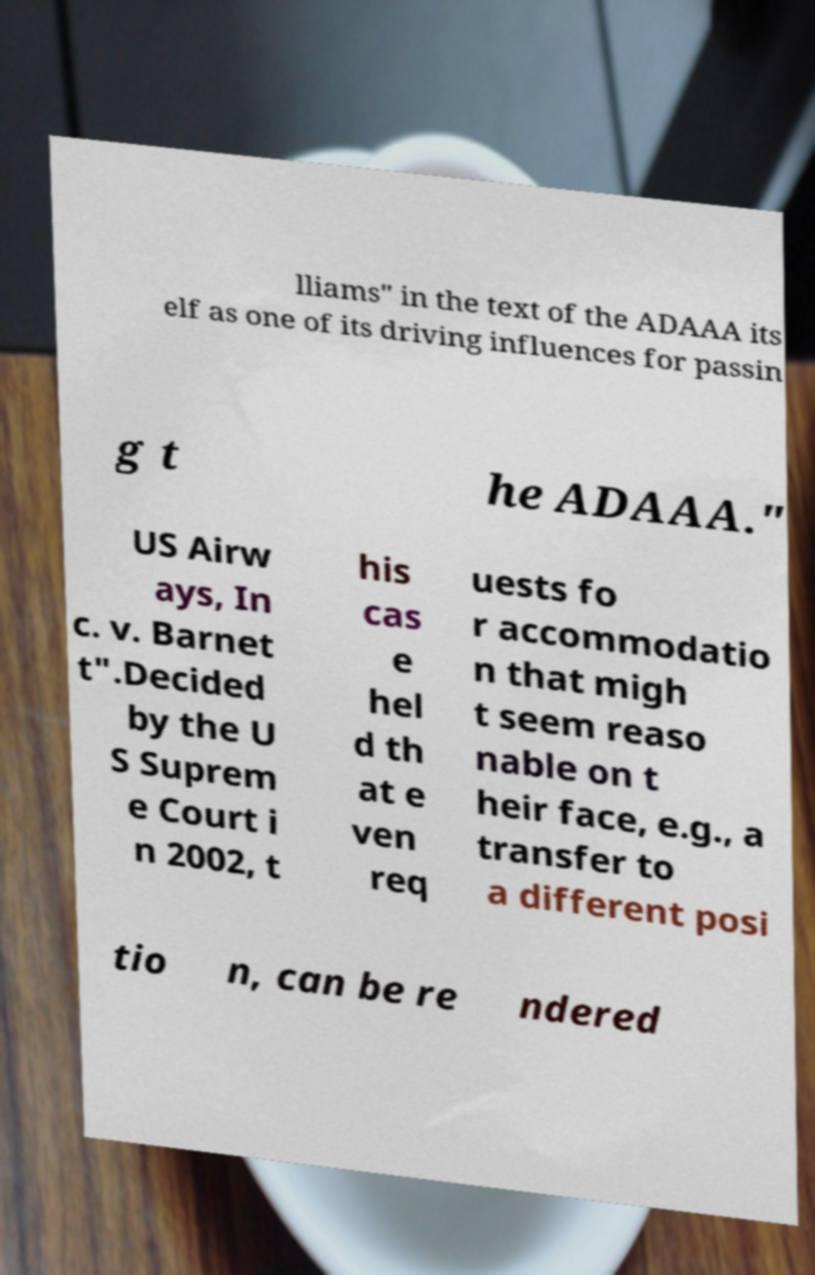Please read and relay the text visible in this image. What does it say? lliams" in the text of the ADAAA its elf as one of its driving influences for passin g t he ADAAA." US Airw ays, In c. v. Barnet t".Decided by the U S Suprem e Court i n 2002, t his cas e hel d th at e ven req uests fo r accommodatio n that migh t seem reaso nable on t heir face, e.g., a transfer to a different posi tio n, can be re ndered 